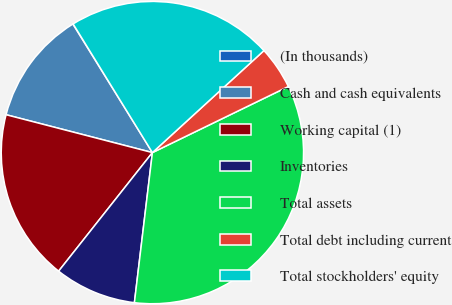Convert chart. <chart><loc_0><loc_0><loc_500><loc_500><pie_chart><fcel>(In thousands)<fcel>Cash and cash equivalents<fcel>Working capital (1)<fcel>Inventories<fcel>Total assets<fcel>Total debt including current<fcel>Total stockholders' equity<nl><fcel>0.03%<fcel>12.15%<fcel>18.38%<fcel>8.75%<fcel>34.1%<fcel>4.59%<fcel>22.0%<nl></chart> 